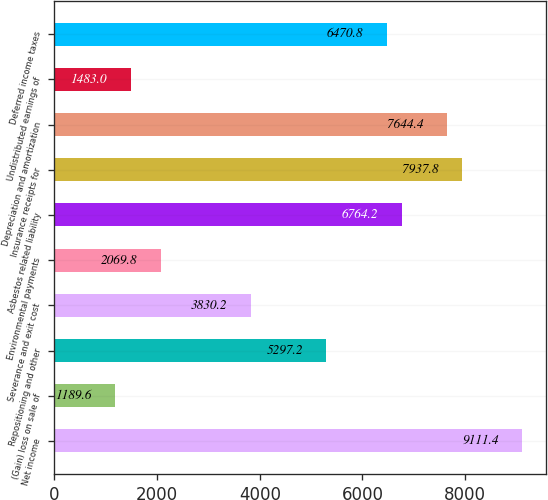Convert chart. <chart><loc_0><loc_0><loc_500><loc_500><bar_chart><fcel>Net income<fcel>(Gain) loss on sale of<fcel>Repositioning and other<fcel>Severance and exit cost<fcel>Environmental payments<fcel>Asbestos related liability<fcel>Insurance receipts for<fcel>Depreciation and amortization<fcel>Undistributed earnings of<fcel>Deferred income taxes<nl><fcel>9111.4<fcel>1189.6<fcel>5297.2<fcel>3830.2<fcel>2069.8<fcel>6764.2<fcel>7937.8<fcel>7644.4<fcel>1483<fcel>6470.8<nl></chart> 